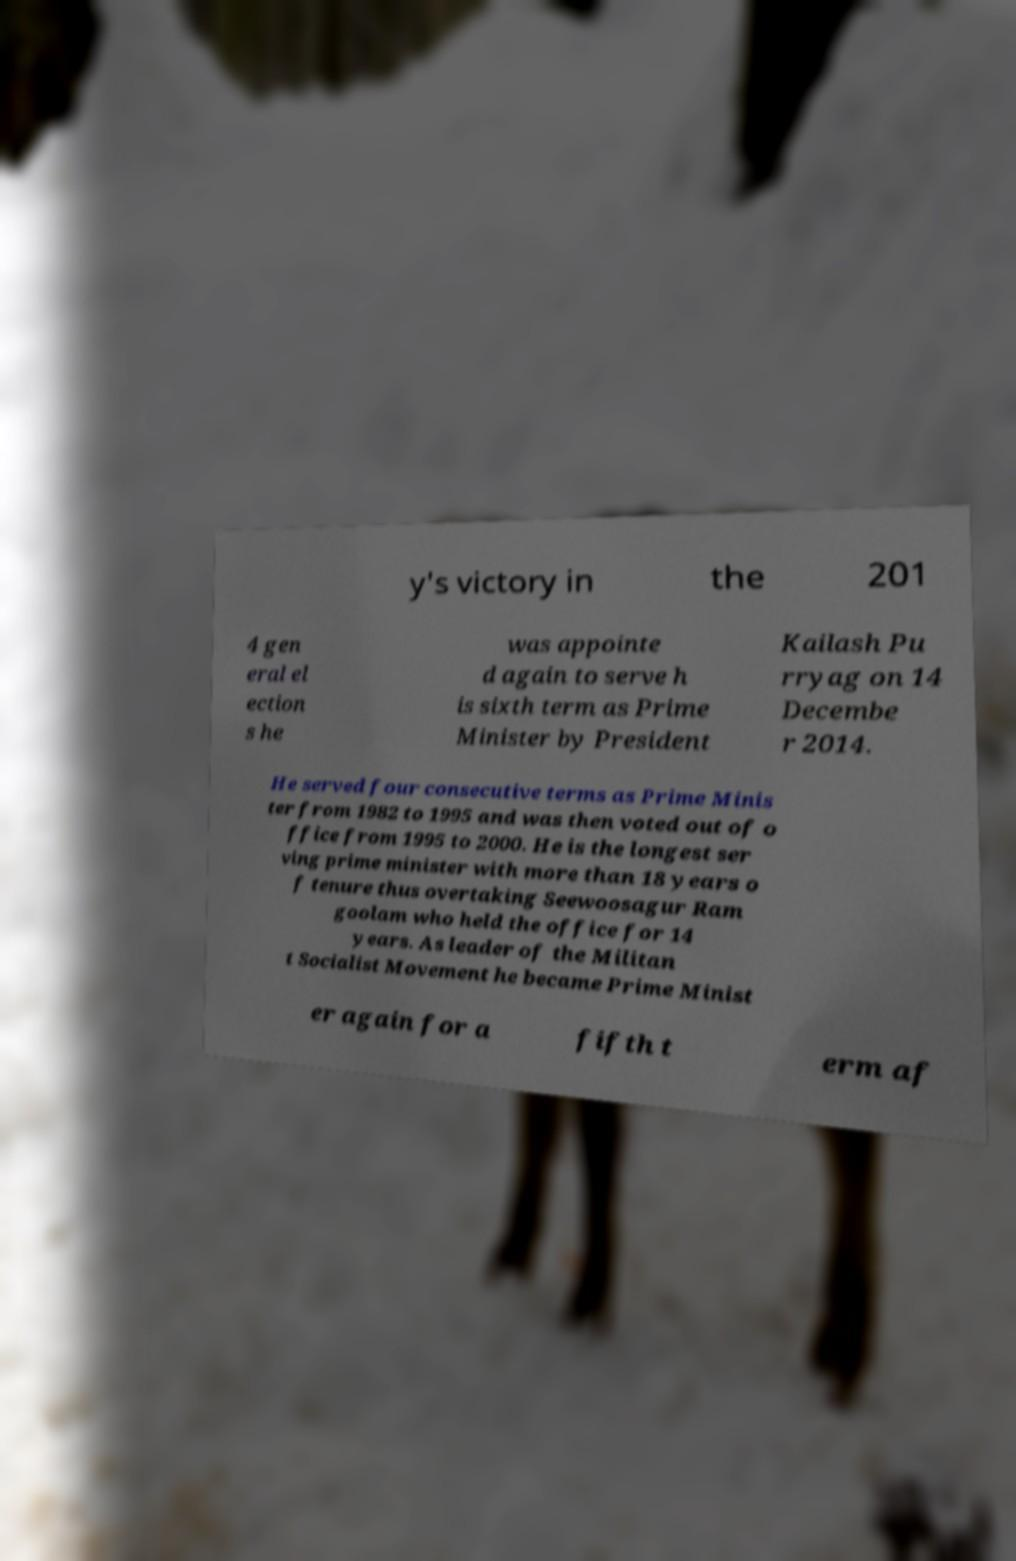Can you read and provide the text displayed in the image?This photo seems to have some interesting text. Can you extract and type it out for me? y's victory in the 201 4 gen eral el ection s he was appointe d again to serve h is sixth term as Prime Minister by President Kailash Pu rryag on 14 Decembe r 2014. He served four consecutive terms as Prime Minis ter from 1982 to 1995 and was then voted out of o ffice from 1995 to 2000. He is the longest ser ving prime minister with more than 18 years o f tenure thus overtaking Seewoosagur Ram goolam who held the office for 14 years. As leader of the Militan t Socialist Movement he became Prime Minist er again for a fifth t erm af 